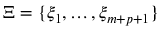<formula> <loc_0><loc_0><loc_500><loc_500>\Xi = \{ \xi _ { 1 } , \dots , \xi _ { m + p + 1 } \}</formula> 